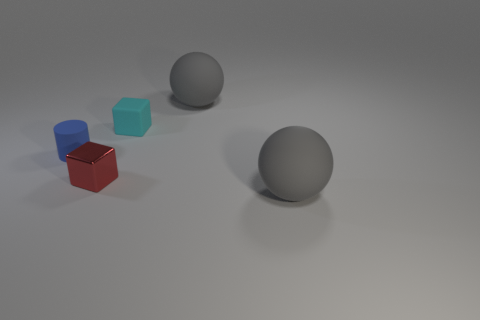Add 4 small metallic blocks. How many objects exist? 9 Subtract 1 blocks. How many blocks are left? 1 Subtract all matte cylinders. Subtract all cubes. How many objects are left? 2 Add 3 small cyan things. How many small cyan things are left? 4 Add 3 small purple cubes. How many small purple cubes exist? 3 Subtract all red cubes. How many cubes are left? 1 Subtract 0 gray blocks. How many objects are left? 5 Subtract all balls. How many objects are left? 3 Subtract all blue cubes. Subtract all blue balls. How many cubes are left? 2 Subtract all purple cubes. How many cyan cylinders are left? 0 